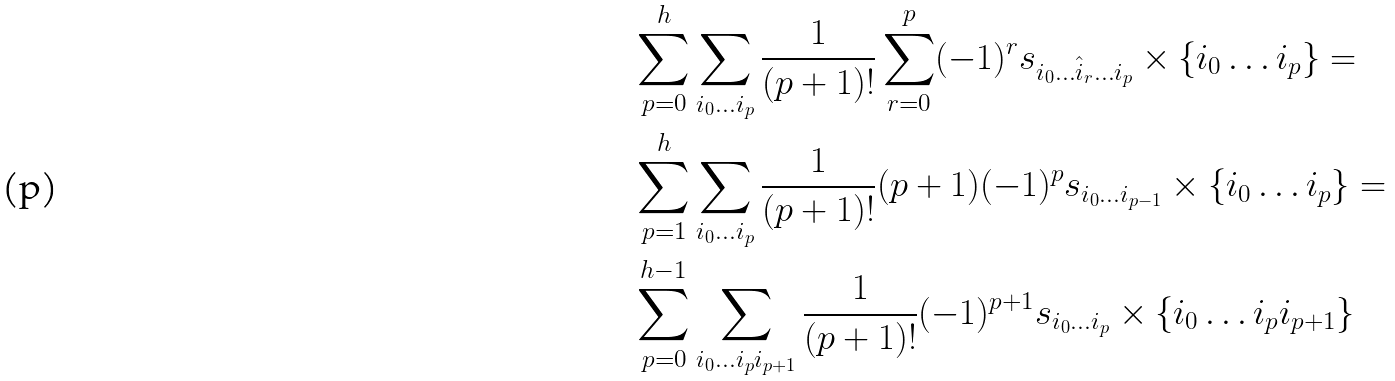Convert formula to latex. <formula><loc_0><loc_0><loc_500><loc_500>& \sum _ { p = 0 } ^ { h } \sum _ { i _ { 0 } \dots i _ { p } } \frac { 1 } { ( p + 1 ) ! } \sum _ { r = 0 } ^ { p } ( - 1 ) ^ { r } s _ { i _ { 0 } \dots \hat { i } _ { r } \dots i _ { p } } \times \{ { i _ { 0 } \dots i _ { p } } \} = \\ & \sum _ { p = 1 } ^ { h } \sum _ { i _ { 0 } \dots i _ { p } } \frac { 1 } { ( p + 1 ) ! } ( p + 1 ) ( - 1 ) ^ { p } s _ { i _ { 0 } \dots i _ { p - 1 } } \times \{ { i _ { 0 } \dots i _ { p } } \} = \\ & \sum _ { p = 0 } ^ { h - 1 } \sum _ { i _ { 0 } \dots i _ { p } i _ { p + 1 } } \frac { 1 } { ( p + 1 ) ! } ( - 1 ) ^ { p + 1 } s _ { i _ { 0 } \dots i _ { p } } \times \{ { i _ { 0 } \dots i _ { p } i _ { p + 1 } } \}</formula> 